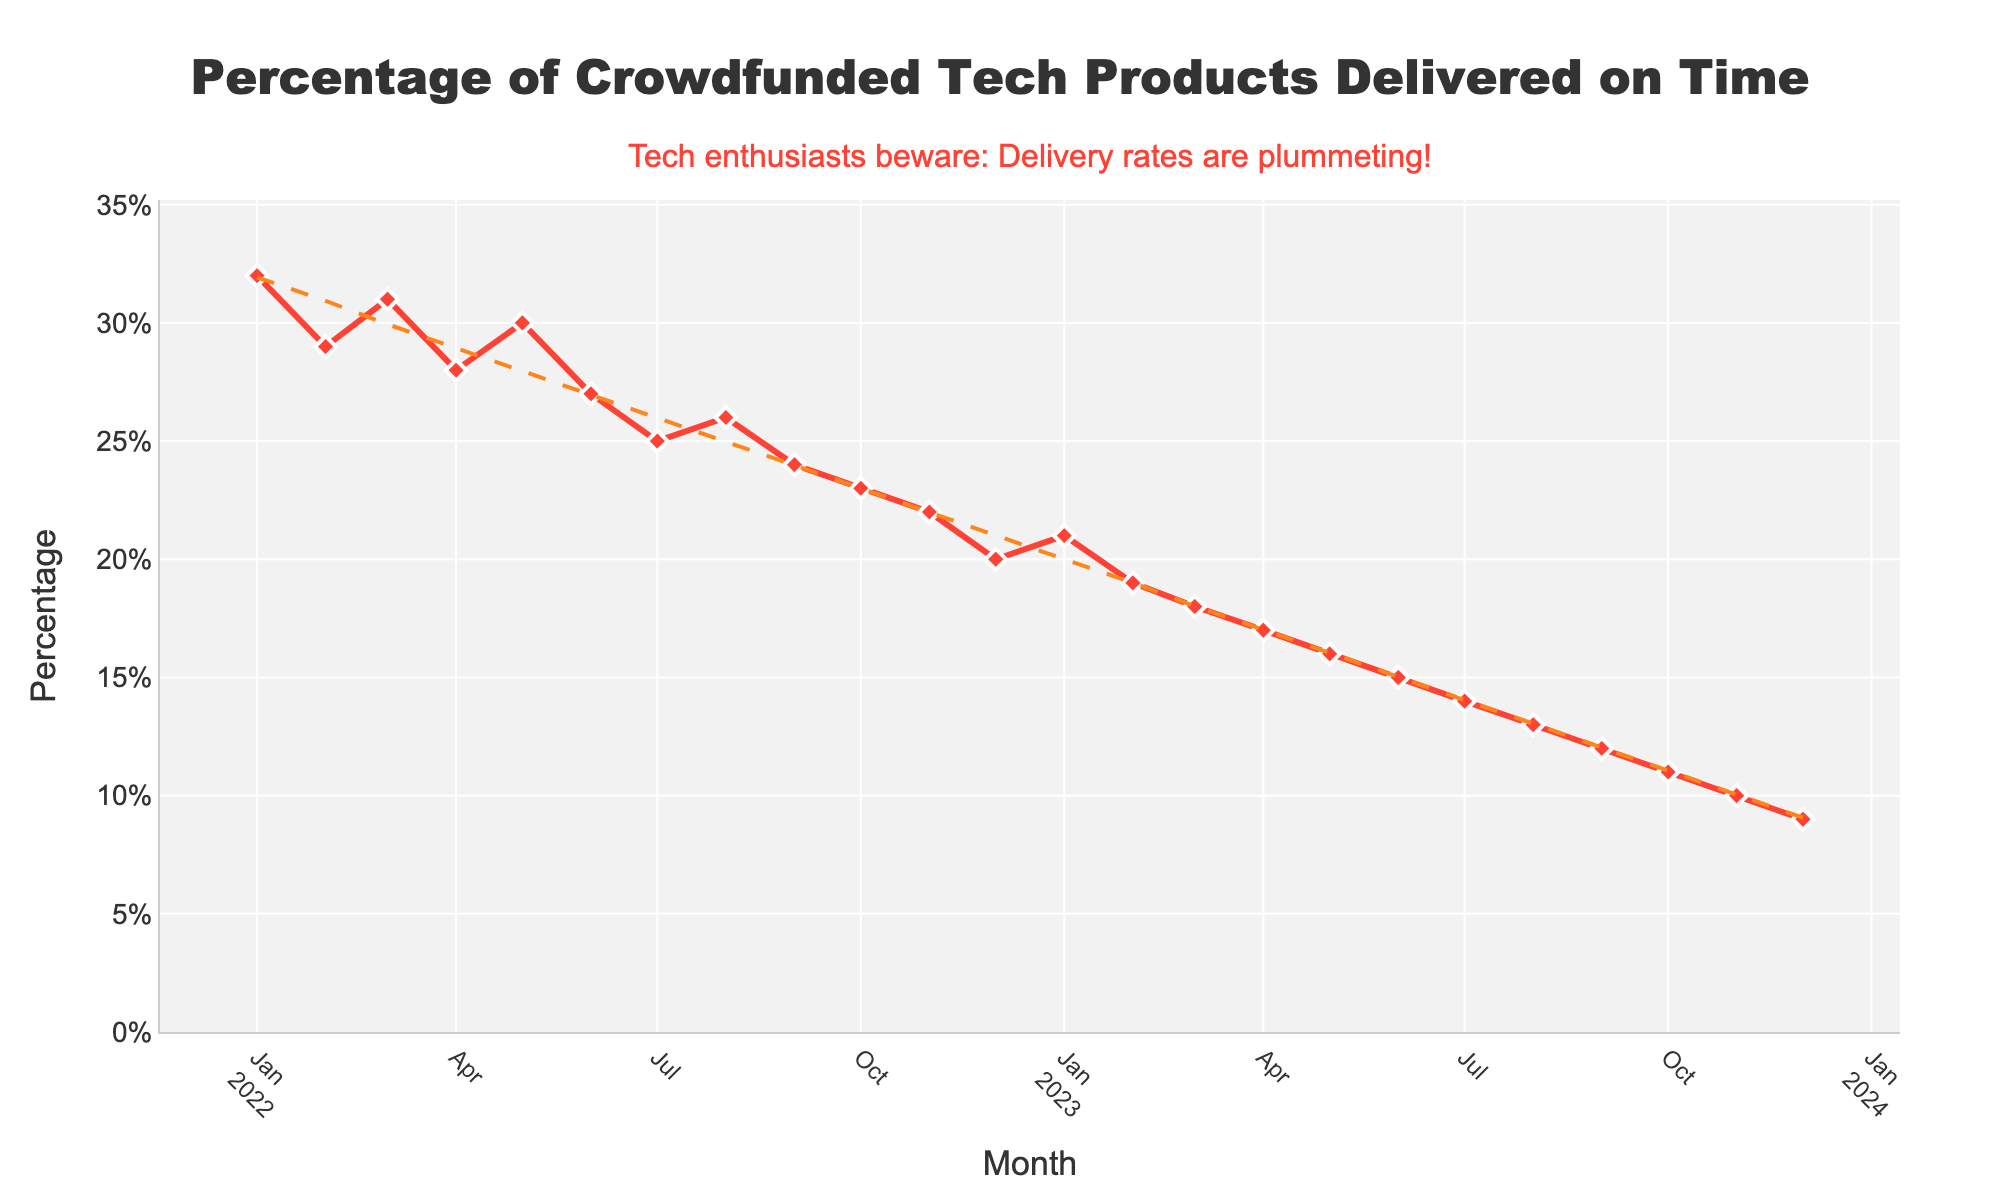What's the median percentage of crowdfunded tech products delivered on time in 2022? Median is the middle value when numbers are sorted. The percentages for 2022 are: 32, 29, 31, 28, 30, 27, 25, 26, 24, 23, 22, 20. Sorting these: 20, 22, 23, 24, 25, 26, 27, 28, 29, 30, 31, 32. Median is average of 26 and 27, so (26+27)/2 = 26.5
Answer: 26.5% How does the percentage of products delivered on time in Jan 2022 compare to Dec 2023? Percentage in Jan 2022 is 32% and in Dec 2023 is 9%. Jan 2022 is greater than Dec 2023
Answer: Jan 2022 > Dec 2023 What month in 2023 had the highest percentage of tech products delivered on time? From the figure, among the months in 2023, January had the highest percentage with 21%
Answer: January 2023 Describe the general trend of the percentage of tech products delivered on time from Jan 2022 to Dec 2023? The trend line added to the chart shows a continuous decline in the percentage of tech products delivered on time from Jan 2022 to Dec 2023, confirming a downward trend.
Answer: Downward trend By how much did the percentage of on-time tech product deliveries decrease from Feb 2022 to Feb 2023? Percentage in Feb 2022 is 29%, and in Feb 2023 is 19%. Subtract 19 from 29 to get the difference, 29 - 19 = 10%
Answer: 10% What is the lowest percentage of tech products delivered on time recorded in the given data, and in which month did it occur? The lowest percentage is 9%, which is recorded in Dec 2023 according to the figure
Answer: 9% in Dec 2023 What is the difference in percentage between the highest and lowest value observed in the chart? Highest value is 32% (Jan 2022) and lowest is 9% (Dec 2023). Subtract 9 from 32 to get the difference, 32 - 9 = 23%
Answer: 23% 